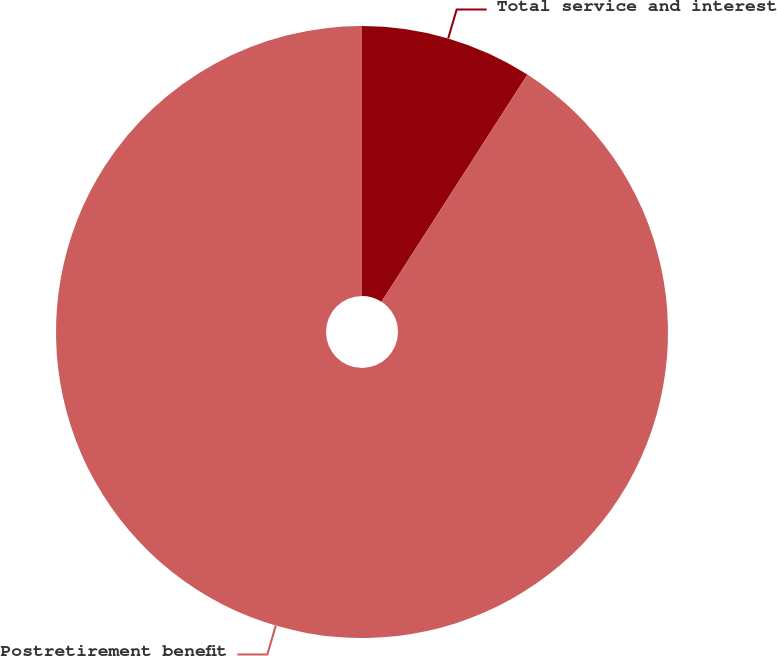Convert chart. <chart><loc_0><loc_0><loc_500><loc_500><pie_chart><fcel>Total service and interest<fcel>Postretirement benefit<nl><fcel>9.09%<fcel>90.91%<nl></chart> 